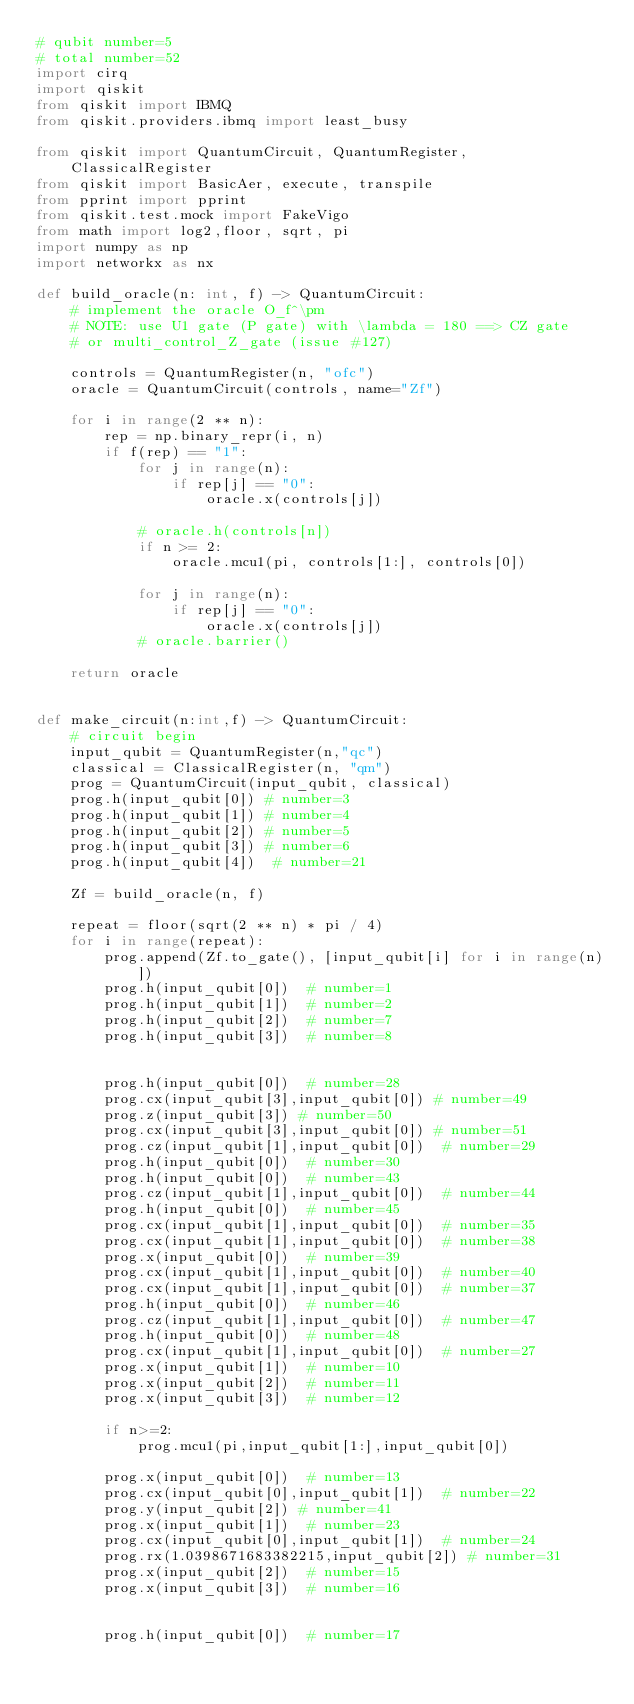<code> <loc_0><loc_0><loc_500><loc_500><_Python_># qubit number=5
# total number=52
import cirq
import qiskit
from qiskit import IBMQ
from qiskit.providers.ibmq import least_busy

from qiskit import QuantumCircuit, QuantumRegister, ClassicalRegister
from qiskit import BasicAer, execute, transpile
from pprint import pprint
from qiskit.test.mock import FakeVigo
from math import log2,floor, sqrt, pi
import numpy as np
import networkx as nx

def build_oracle(n: int, f) -> QuantumCircuit:
    # implement the oracle O_f^\pm
    # NOTE: use U1 gate (P gate) with \lambda = 180 ==> CZ gate
    # or multi_control_Z_gate (issue #127)

    controls = QuantumRegister(n, "ofc")
    oracle = QuantumCircuit(controls, name="Zf")

    for i in range(2 ** n):
        rep = np.binary_repr(i, n)
        if f(rep) == "1":
            for j in range(n):
                if rep[j] == "0":
                    oracle.x(controls[j])

            # oracle.h(controls[n])
            if n >= 2:
                oracle.mcu1(pi, controls[1:], controls[0])

            for j in range(n):
                if rep[j] == "0":
                    oracle.x(controls[j])
            # oracle.barrier()

    return oracle


def make_circuit(n:int,f) -> QuantumCircuit:
    # circuit begin
    input_qubit = QuantumRegister(n,"qc")
    classical = ClassicalRegister(n, "qm")
    prog = QuantumCircuit(input_qubit, classical)
    prog.h(input_qubit[0]) # number=3
    prog.h(input_qubit[1]) # number=4
    prog.h(input_qubit[2]) # number=5
    prog.h(input_qubit[3]) # number=6
    prog.h(input_qubit[4])  # number=21

    Zf = build_oracle(n, f)

    repeat = floor(sqrt(2 ** n) * pi / 4)
    for i in range(repeat):
        prog.append(Zf.to_gate(), [input_qubit[i] for i in range(n)])
        prog.h(input_qubit[0])  # number=1
        prog.h(input_qubit[1])  # number=2
        prog.h(input_qubit[2])  # number=7
        prog.h(input_qubit[3])  # number=8


        prog.h(input_qubit[0])  # number=28
        prog.cx(input_qubit[3],input_qubit[0]) # number=49
        prog.z(input_qubit[3]) # number=50
        prog.cx(input_qubit[3],input_qubit[0]) # number=51
        prog.cz(input_qubit[1],input_qubit[0])  # number=29
        prog.h(input_qubit[0])  # number=30
        prog.h(input_qubit[0])  # number=43
        prog.cz(input_qubit[1],input_qubit[0])  # number=44
        prog.h(input_qubit[0])  # number=45
        prog.cx(input_qubit[1],input_qubit[0])  # number=35
        prog.cx(input_qubit[1],input_qubit[0])  # number=38
        prog.x(input_qubit[0])  # number=39
        prog.cx(input_qubit[1],input_qubit[0])  # number=40
        prog.cx(input_qubit[1],input_qubit[0])  # number=37
        prog.h(input_qubit[0])  # number=46
        prog.cz(input_qubit[1],input_qubit[0])  # number=47
        prog.h(input_qubit[0])  # number=48
        prog.cx(input_qubit[1],input_qubit[0])  # number=27
        prog.x(input_qubit[1])  # number=10
        prog.x(input_qubit[2])  # number=11
        prog.x(input_qubit[3])  # number=12

        if n>=2:
            prog.mcu1(pi,input_qubit[1:],input_qubit[0])

        prog.x(input_qubit[0])  # number=13
        prog.cx(input_qubit[0],input_qubit[1])  # number=22
        prog.y(input_qubit[2]) # number=41
        prog.x(input_qubit[1])  # number=23
        prog.cx(input_qubit[0],input_qubit[1])  # number=24
        prog.rx(1.0398671683382215,input_qubit[2]) # number=31
        prog.x(input_qubit[2])  # number=15
        prog.x(input_qubit[3])  # number=16


        prog.h(input_qubit[0])  # number=17</code> 